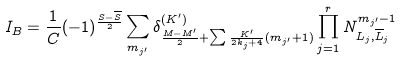<formula> <loc_0><loc_0><loc_500><loc_500>I _ { B } = \frac { 1 } { C } ( - 1 ) ^ { \frac { S - { \overline { S } } } 2 } \sum _ { m _ { j ^ { \prime } } } \delta ^ { ( K ^ { \prime } ) } _ { \frac { M - M ^ { \prime } } { 2 } + \sum \frac { K ^ { \prime } } { 2 k _ { j } + 4 } ( m _ { j ^ { \prime } } + 1 ) } \prod _ { j = 1 } ^ { r } N ^ { m _ { j ^ { \prime } } - 1 } _ { L _ { j } , \overline { L } _ { j } }</formula> 